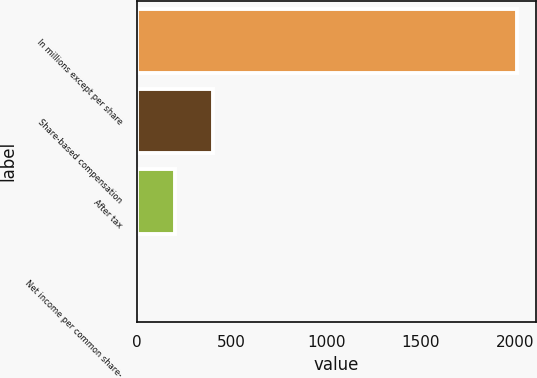<chart> <loc_0><loc_0><loc_500><loc_500><bar_chart><fcel>In millions except per share<fcel>Share-based compensation<fcel>After tax<fcel>Net income per common share-<nl><fcel>2008<fcel>401.65<fcel>200.86<fcel>0.07<nl></chart> 